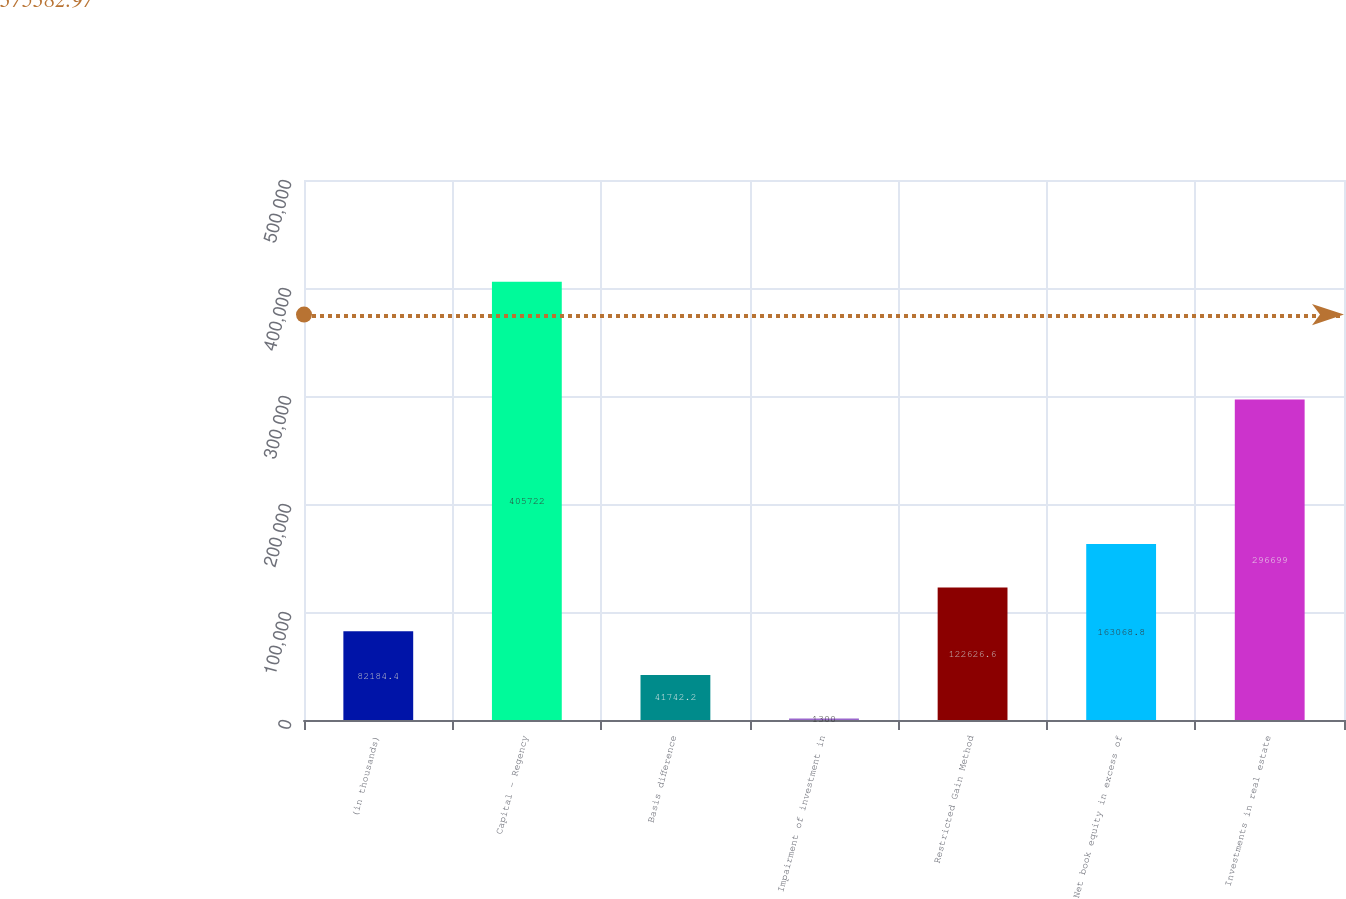<chart> <loc_0><loc_0><loc_500><loc_500><bar_chart><fcel>(in thousands)<fcel>Capital - Regency<fcel>Basis difference<fcel>Impairment of investment in<fcel>Restricted Gain Method<fcel>Net book equity in excess of<fcel>Investments in real estate<nl><fcel>82184.4<fcel>405722<fcel>41742.2<fcel>1300<fcel>122627<fcel>163069<fcel>296699<nl></chart> 